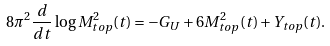<formula> <loc_0><loc_0><loc_500><loc_500>8 \pi ^ { 2 } \frac { d } { d t } \log M _ { t o p } ^ { 2 } ( t ) = - G _ { U } + 6 M _ { t o p } ^ { 2 } ( t ) + Y _ { t o p } ( t ) .</formula> 